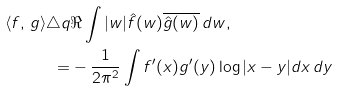Convert formula to latex. <formula><loc_0><loc_0><loc_500><loc_500>\langle f , \, g \rangle \triangle q & \Re \int | w | \hat { f } ( w ) \overline { \hat { g } ( w ) } \, d w , \\ = & - \frac { 1 } { 2 \pi ^ { 2 } } \int f ^ { \prime } ( x ) g ^ { \prime } ( y ) \log | x - y | d x \, d y</formula> 